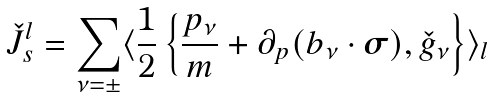<formula> <loc_0><loc_0><loc_500><loc_500>\check { J } ^ { l } _ { s } = \sum _ { \nu = \pm } \langle \frac { 1 } { 2 } \left \{ \frac { { p } _ { \nu } } { m } + \partial _ { p } ( { b } _ { \nu } \cdot { \boldsymbol \sigma } ) , \check { g } _ { \nu } \right \} \rangle _ { l }</formula> 